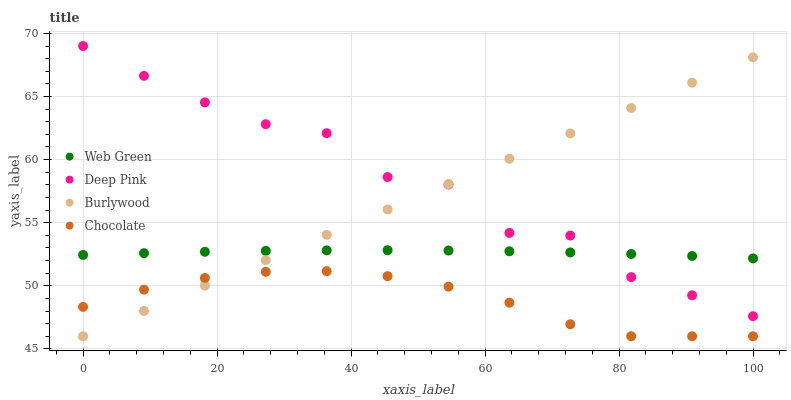Does Chocolate have the minimum area under the curve?
Answer yes or no. Yes. Does Deep Pink have the maximum area under the curve?
Answer yes or no. Yes. Does Web Green have the minimum area under the curve?
Answer yes or no. No. Does Web Green have the maximum area under the curve?
Answer yes or no. No. Is Burlywood the smoothest?
Answer yes or no. Yes. Is Deep Pink the roughest?
Answer yes or no. Yes. Is Web Green the smoothest?
Answer yes or no. No. Is Web Green the roughest?
Answer yes or no. No. Does Burlywood have the lowest value?
Answer yes or no. Yes. Does Deep Pink have the lowest value?
Answer yes or no. No. Does Deep Pink have the highest value?
Answer yes or no. Yes. Does Web Green have the highest value?
Answer yes or no. No. Is Chocolate less than Web Green?
Answer yes or no. Yes. Is Deep Pink greater than Chocolate?
Answer yes or no. Yes. Does Deep Pink intersect Web Green?
Answer yes or no. Yes. Is Deep Pink less than Web Green?
Answer yes or no. No. Is Deep Pink greater than Web Green?
Answer yes or no. No. Does Chocolate intersect Web Green?
Answer yes or no. No. 